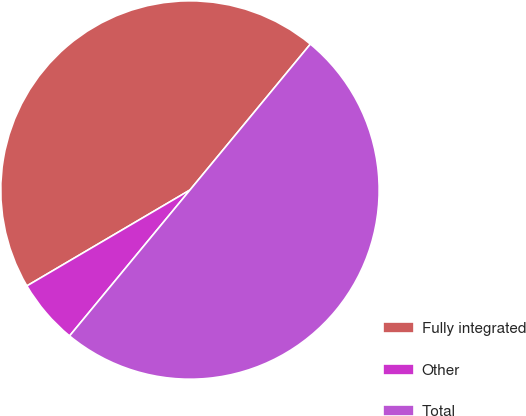Convert chart. <chart><loc_0><loc_0><loc_500><loc_500><pie_chart><fcel>Fully integrated<fcel>Other<fcel>Total<nl><fcel>44.44%<fcel>5.56%<fcel>50.0%<nl></chart> 